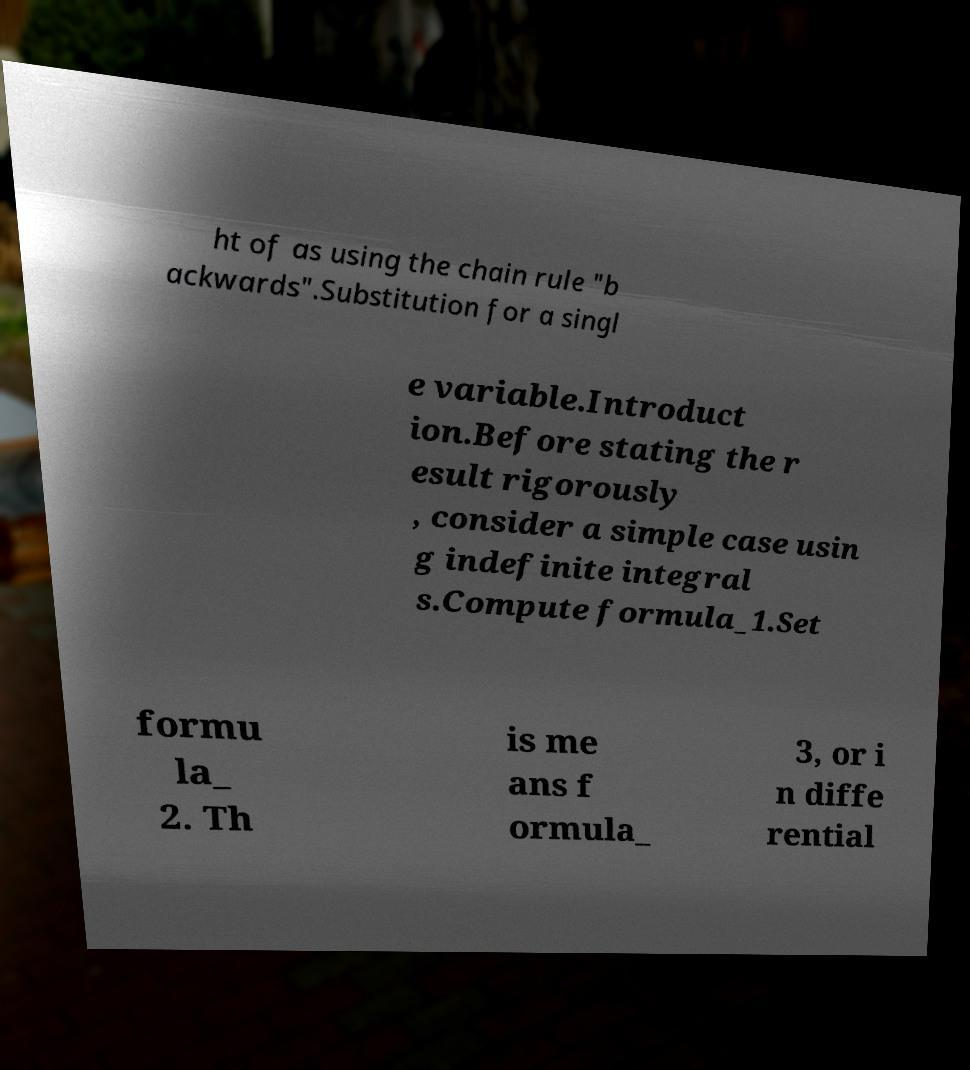Could you assist in decoding the text presented in this image and type it out clearly? ht of as using the chain rule "b ackwards".Substitution for a singl e variable.Introduct ion.Before stating the r esult rigorously , consider a simple case usin g indefinite integral s.Compute formula_1.Set formu la_ 2. Th is me ans f ormula_ 3, or i n diffe rential 